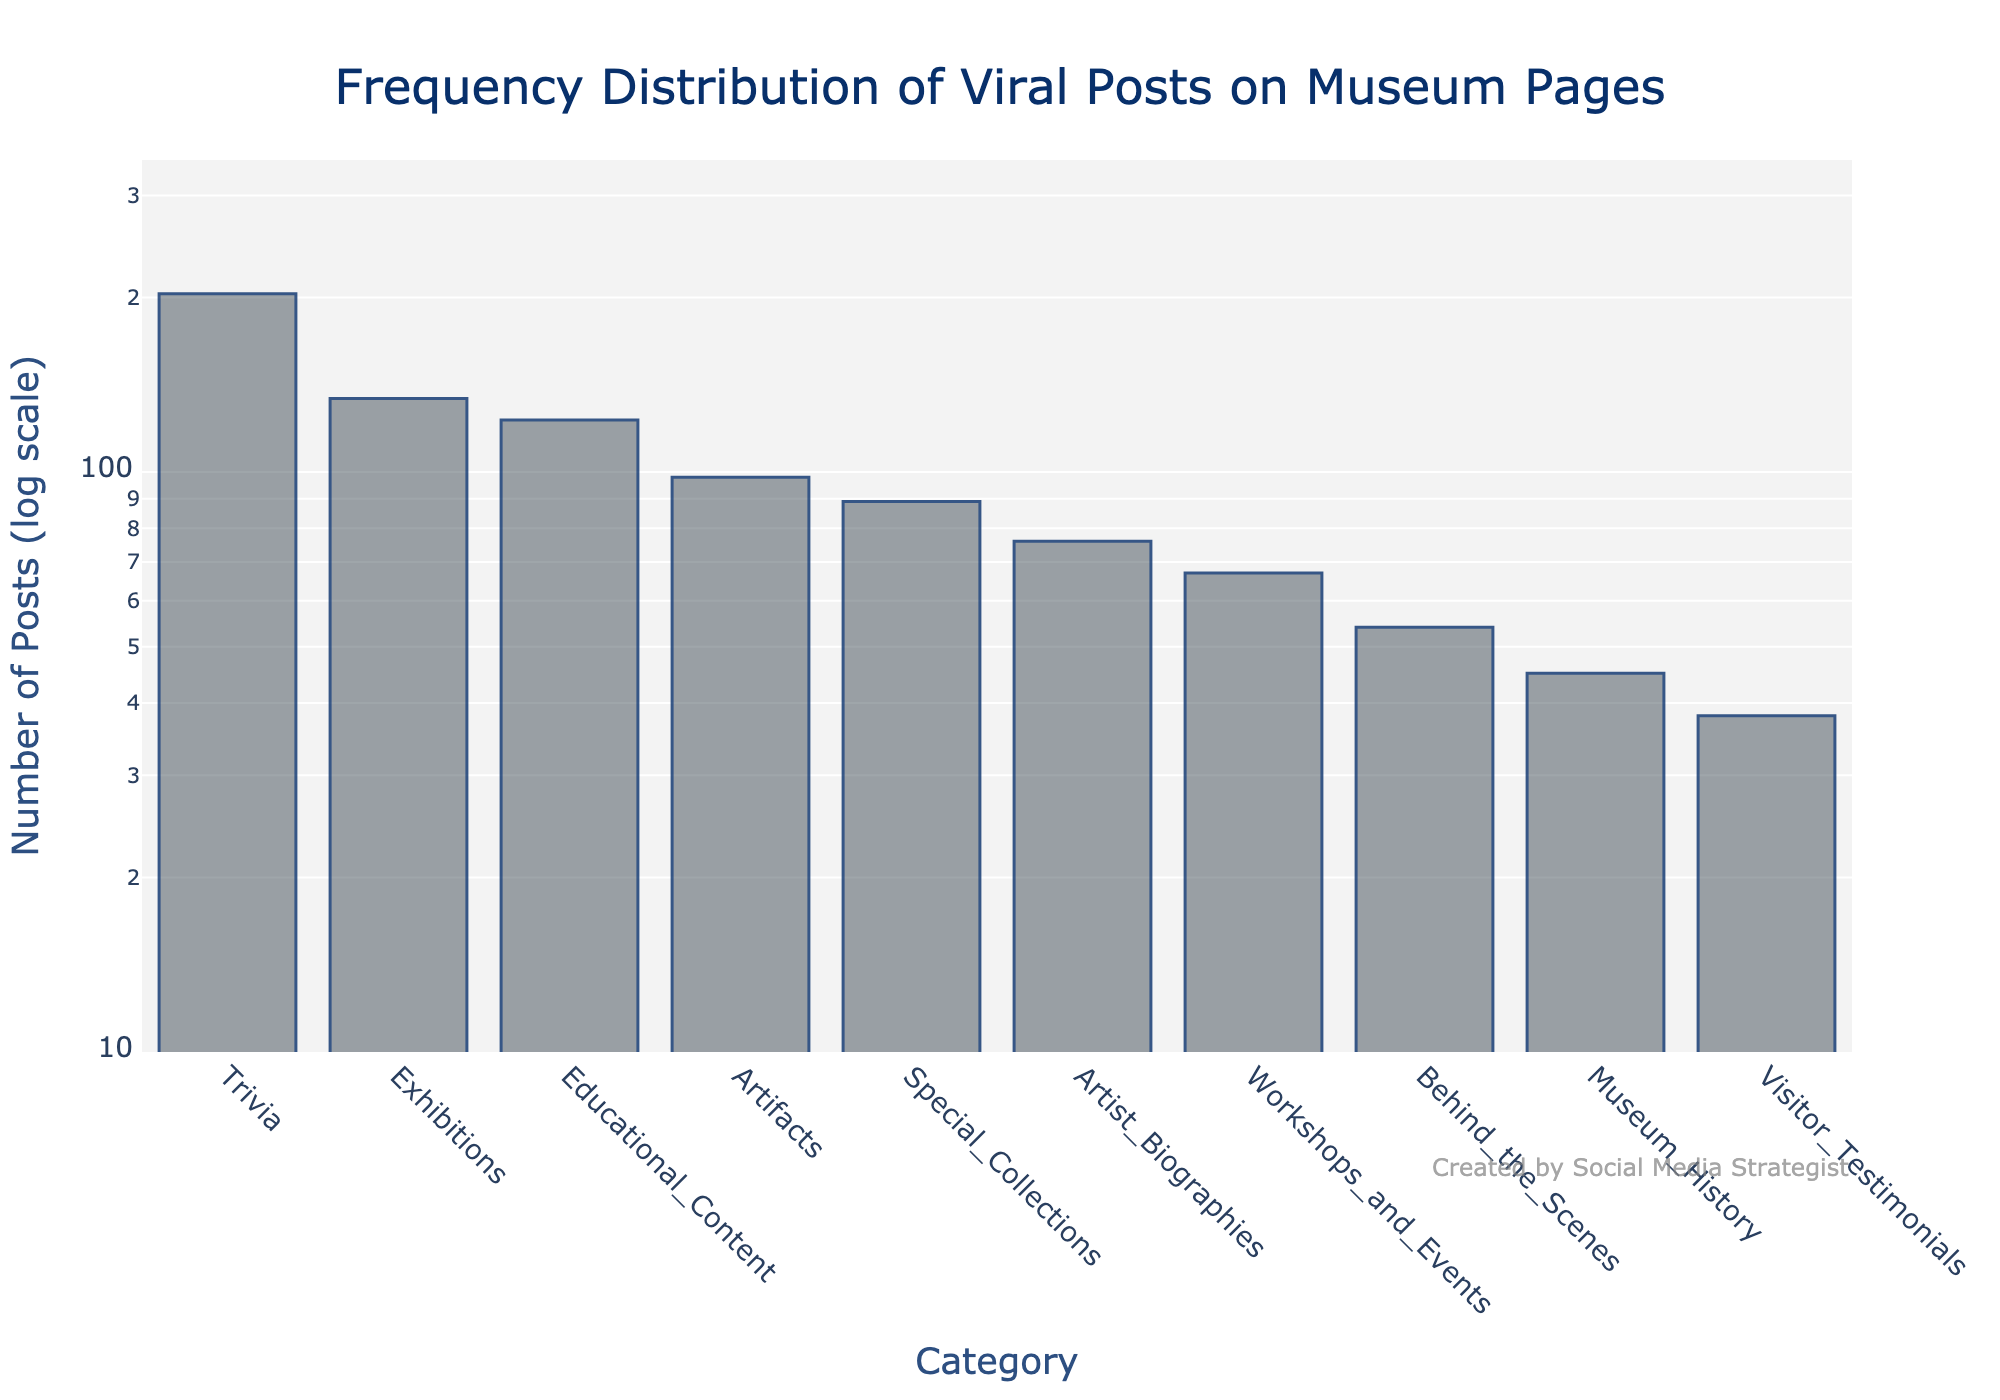What's the title of the plot? The title of the plot is located at the top center of the figure. It reads "Frequency Distribution of Viral Posts on Museum Pages".
Answer: Frequency Distribution of Viral Posts on Museum Pages How many categories are shown in the plot? Count the bars presented on the X-axis, each representing a category. There are a total of 10 bars, each corresponding to a different category.
Answer: 10 Which category has the highest number of posts? Identify the tallest bar in the figure, which represents the highest number of posts. The category at the base of this bar is "Trivia".
Answer: Trivia How is the Y-axis labeled in this plot? The Y-axis label is located next to the Y-axis. It reads "Number of Posts (log scale)".
Answer: Number of Posts (log scale) What is the range of the Y-axis on this log scale plot? The Y-axis range can be observed from the bottom to the top of the axis. It starts at 1 and goes up to around 2.3 (a log scale approximation).
Answer: 1 to 2.3 What categories have fewer posts than Educational Content? Identify categories with bars shorter than the one representing "Educational Content." These categories include Artist Biographies, Behind the Scenes, Workshops and Events, Museum History, Special Collections, and Visitor Testimonials.
Answer: Artist Biographies, Behind the Scenes, Workshops and Events, Museum History, Special Collections, Visitor Testimonials How many more posts does Trivia have compared to Behind the Scenes? Observe the heights of the respective bars. Trivia has 203 posts, and Behind the Scenes has 54 posts. Calculate the difference 203 - 54 = 149.
Answer: 149 Rank the categories from highest to lowest based on the number of posts. Based on the heights of the bars, the categories can be ranked as follows: Trivia, Exhibitions, Educational Content, Artifacts, Special Collections, Workshops and Events, Artist Biographies, Behind the Scenes, Museum History, Visitor Testimonials.
Answer: Trivia, Exhibitions, Educational Content, Artifacts, Special Collections, Workshops and Events, Artist Biographies, Behind the Scenes, Museum History, Visitor Testimonials What's the average number of posts for the categories Workshops and Events, Museum History, and Special Collections? Sum the number of posts for these three categories (67 for Workshops and Events, 45 for Museum History, 89 for Special Collections) and divide by 3 to find the average: (67 + 45 + 89) / 3 = 201 / 3 ≈ 67.
Answer: 67 Which category has fewer posts than Special Collections but more than Musem History? Identify the category with a number of posts that fall between 89 (Special Collections) and 45 (Museum History). This category is Workshops and Events with 67 posts.
Answer: Workshops and Events 